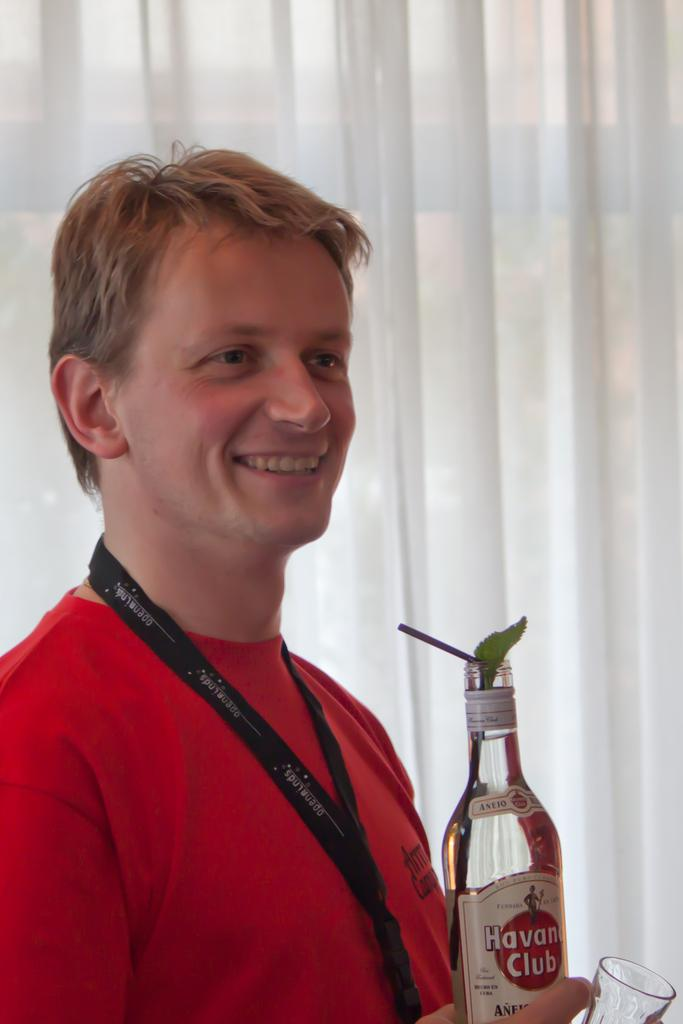What is the man in the image doing? The man is standing in the image and smiling. What is the man holding in the image? The man is holding a bottle in the image. What is the name of the bottle? The bottle is named "Club". What can be seen in the background of the image? There is a curtain in the background of the image. What song is the man singing in the image? There is no indication in the image that the man is singing a song, so it cannot be determined from the picture. 